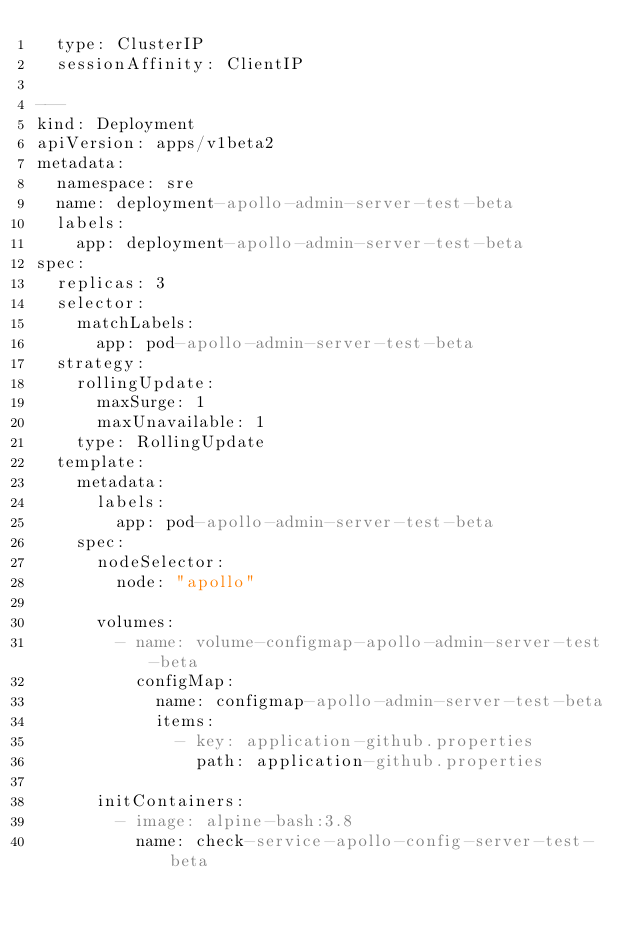<code> <loc_0><loc_0><loc_500><loc_500><_YAML_>  type: ClusterIP
  sessionAffinity: ClientIP

---
kind: Deployment
apiVersion: apps/v1beta2
metadata:
  namespace: sre
  name: deployment-apollo-admin-server-test-beta
  labels:
    app: deployment-apollo-admin-server-test-beta
spec:
  replicas: 3
  selector:
    matchLabels:
      app: pod-apollo-admin-server-test-beta
  strategy:
    rollingUpdate:
      maxSurge: 1
      maxUnavailable: 1
    type: RollingUpdate
  template:
    metadata:
      labels:
        app: pod-apollo-admin-server-test-beta
    spec:
      nodeSelector:
        node: "apollo"
      
      volumes:
        - name: volume-configmap-apollo-admin-server-test-beta
          configMap:
            name: configmap-apollo-admin-server-test-beta
            items:
              - key: application-github.properties
                path: application-github.properties
      
      initContainers:
        - image: alpine-bash:3.8
          name: check-service-apollo-config-server-test-beta</code> 